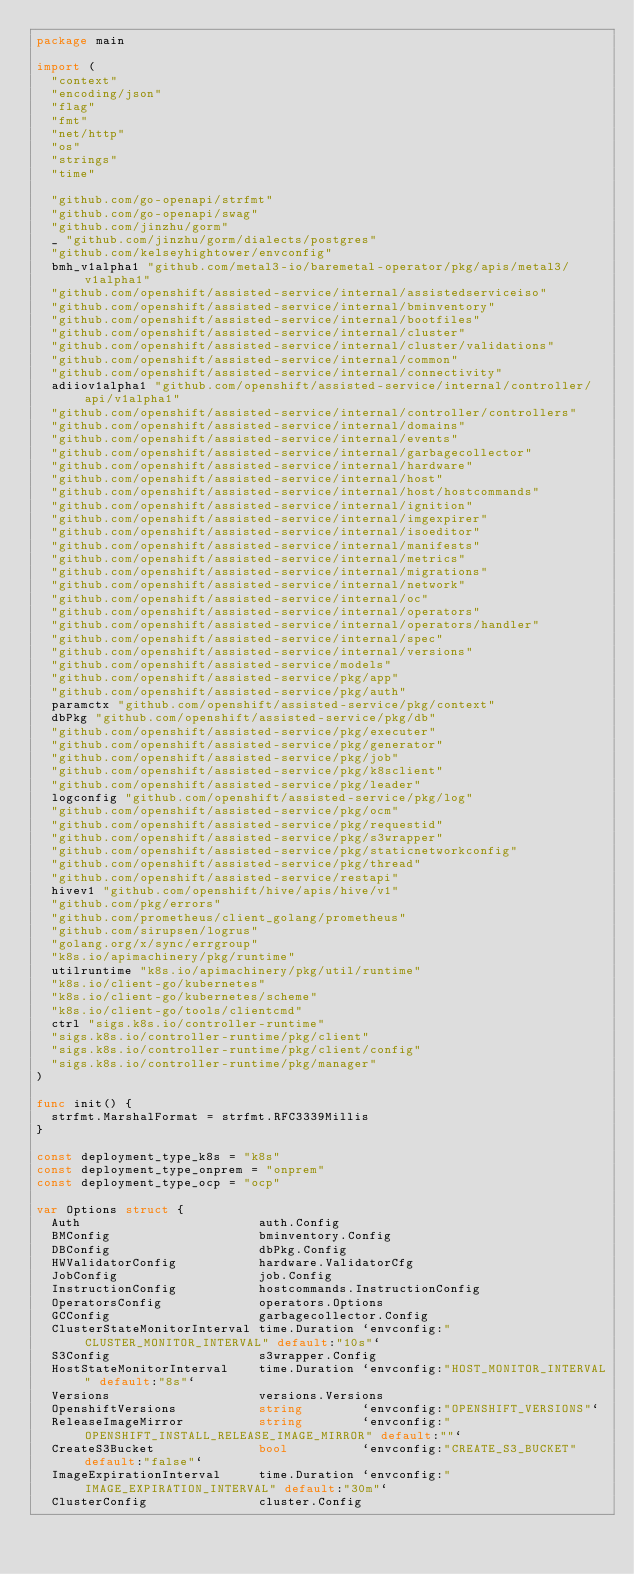<code> <loc_0><loc_0><loc_500><loc_500><_Go_>package main

import (
	"context"
	"encoding/json"
	"flag"
	"fmt"
	"net/http"
	"os"
	"strings"
	"time"

	"github.com/go-openapi/strfmt"
	"github.com/go-openapi/swag"
	"github.com/jinzhu/gorm"
	_ "github.com/jinzhu/gorm/dialects/postgres"
	"github.com/kelseyhightower/envconfig"
	bmh_v1alpha1 "github.com/metal3-io/baremetal-operator/pkg/apis/metal3/v1alpha1"
	"github.com/openshift/assisted-service/internal/assistedserviceiso"
	"github.com/openshift/assisted-service/internal/bminventory"
	"github.com/openshift/assisted-service/internal/bootfiles"
	"github.com/openshift/assisted-service/internal/cluster"
	"github.com/openshift/assisted-service/internal/cluster/validations"
	"github.com/openshift/assisted-service/internal/common"
	"github.com/openshift/assisted-service/internal/connectivity"
	adiiov1alpha1 "github.com/openshift/assisted-service/internal/controller/api/v1alpha1"
	"github.com/openshift/assisted-service/internal/controller/controllers"
	"github.com/openshift/assisted-service/internal/domains"
	"github.com/openshift/assisted-service/internal/events"
	"github.com/openshift/assisted-service/internal/garbagecollector"
	"github.com/openshift/assisted-service/internal/hardware"
	"github.com/openshift/assisted-service/internal/host"
	"github.com/openshift/assisted-service/internal/host/hostcommands"
	"github.com/openshift/assisted-service/internal/ignition"
	"github.com/openshift/assisted-service/internal/imgexpirer"
	"github.com/openshift/assisted-service/internal/isoeditor"
	"github.com/openshift/assisted-service/internal/manifests"
	"github.com/openshift/assisted-service/internal/metrics"
	"github.com/openshift/assisted-service/internal/migrations"
	"github.com/openshift/assisted-service/internal/network"
	"github.com/openshift/assisted-service/internal/oc"
	"github.com/openshift/assisted-service/internal/operators"
	"github.com/openshift/assisted-service/internal/operators/handler"
	"github.com/openshift/assisted-service/internal/spec"
	"github.com/openshift/assisted-service/internal/versions"
	"github.com/openshift/assisted-service/models"
	"github.com/openshift/assisted-service/pkg/app"
	"github.com/openshift/assisted-service/pkg/auth"
	paramctx "github.com/openshift/assisted-service/pkg/context"
	dbPkg "github.com/openshift/assisted-service/pkg/db"
	"github.com/openshift/assisted-service/pkg/executer"
	"github.com/openshift/assisted-service/pkg/generator"
	"github.com/openshift/assisted-service/pkg/job"
	"github.com/openshift/assisted-service/pkg/k8sclient"
	"github.com/openshift/assisted-service/pkg/leader"
	logconfig "github.com/openshift/assisted-service/pkg/log"
	"github.com/openshift/assisted-service/pkg/ocm"
	"github.com/openshift/assisted-service/pkg/requestid"
	"github.com/openshift/assisted-service/pkg/s3wrapper"
	"github.com/openshift/assisted-service/pkg/staticnetworkconfig"
	"github.com/openshift/assisted-service/pkg/thread"
	"github.com/openshift/assisted-service/restapi"
	hivev1 "github.com/openshift/hive/apis/hive/v1"
	"github.com/pkg/errors"
	"github.com/prometheus/client_golang/prometheus"
	"github.com/sirupsen/logrus"
	"golang.org/x/sync/errgroup"
	"k8s.io/apimachinery/pkg/runtime"
	utilruntime "k8s.io/apimachinery/pkg/util/runtime"
	"k8s.io/client-go/kubernetes"
	"k8s.io/client-go/kubernetes/scheme"
	"k8s.io/client-go/tools/clientcmd"
	ctrl "sigs.k8s.io/controller-runtime"
	"sigs.k8s.io/controller-runtime/pkg/client"
	"sigs.k8s.io/controller-runtime/pkg/client/config"
	"sigs.k8s.io/controller-runtime/pkg/manager"
)

func init() {
	strfmt.MarshalFormat = strfmt.RFC3339Millis
}

const deployment_type_k8s = "k8s"
const deployment_type_onprem = "onprem"
const deployment_type_ocp = "ocp"

var Options struct {
	Auth                        auth.Config
	BMConfig                    bminventory.Config
	DBConfig                    dbPkg.Config
	HWValidatorConfig           hardware.ValidatorCfg
	JobConfig                   job.Config
	InstructionConfig           hostcommands.InstructionConfig
	OperatorsConfig             operators.Options
	GCConfig                    garbagecollector.Config
	ClusterStateMonitorInterval time.Duration `envconfig:"CLUSTER_MONITOR_INTERVAL" default:"10s"`
	S3Config                    s3wrapper.Config
	HostStateMonitorInterval    time.Duration `envconfig:"HOST_MONITOR_INTERVAL" default:"8s"`
	Versions                    versions.Versions
	OpenshiftVersions           string        `envconfig:"OPENSHIFT_VERSIONS"`
	ReleaseImageMirror          string        `envconfig:"OPENSHIFT_INSTALL_RELEASE_IMAGE_MIRROR" default:""`
	CreateS3Bucket              bool          `envconfig:"CREATE_S3_BUCKET" default:"false"`
	ImageExpirationInterval     time.Duration `envconfig:"IMAGE_EXPIRATION_INTERVAL" default:"30m"`
	ClusterConfig               cluster.Config</code> 